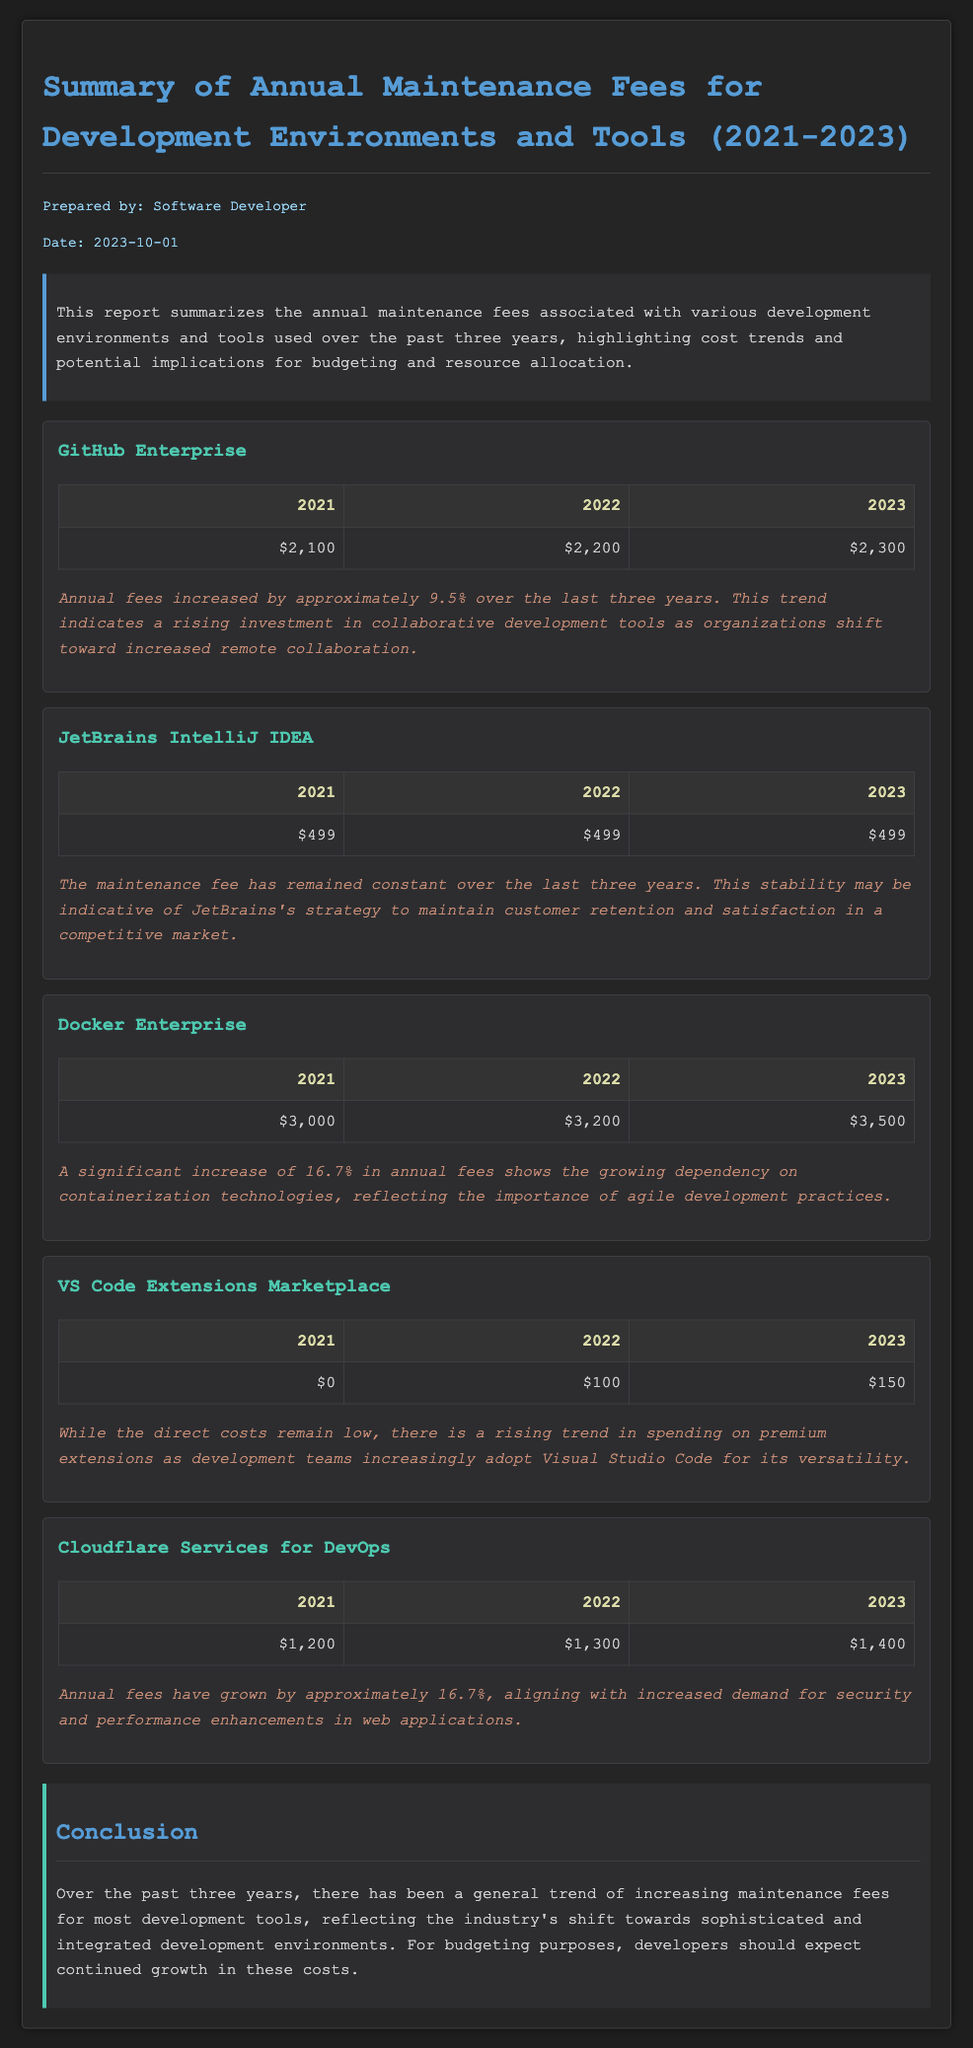what is the total maintenance fee for GitHub Enterprise in 2023? The fee for GitHub Enterprise in 2023 is listed in the document.
Answer: $2,300 how much did Docker Enterprise increase its fees from 2021 to 2023? The increase can be calculated by subtracting the fees in 2021 from the fees in 2023 as shown.
Answer: $500 what was the fee for JetBrains IntelliJ IDEA in 2021? The document states the fee for JetBrains IntelliJ IDEA in 2021.
Answer: $499 how much did the fees for Cloudflare Services grow from 2022 to 2023? The difference in fees between 2022 and 2023 can be extracted from the table in the document.
Answer: $100 which tool had a fee increase of 16.7%? The relevant section compares the fees of different tools, pointing out specific percentage increases.
Answer: Docker Enterprise what trend is observed for VS Code Extensions Marketplace fees? The document describes the fee trends for VS Code Extensions Marketplace in the summary.
Answer: Rising trend who prepared the report? The document lists the preparer's name at the beginning.
Answer: Software Developer in which year did the fees for GitHub Enterprise first exceed $2,200? The data presented in the table indicates when the fees crossed that amount.
Answer: 2022 what is the significance of the fee trends noted in the conclusion? The conclusion section provides insights on the broader implications of these fee trends for budgeting.
Answer: Increase in costs 